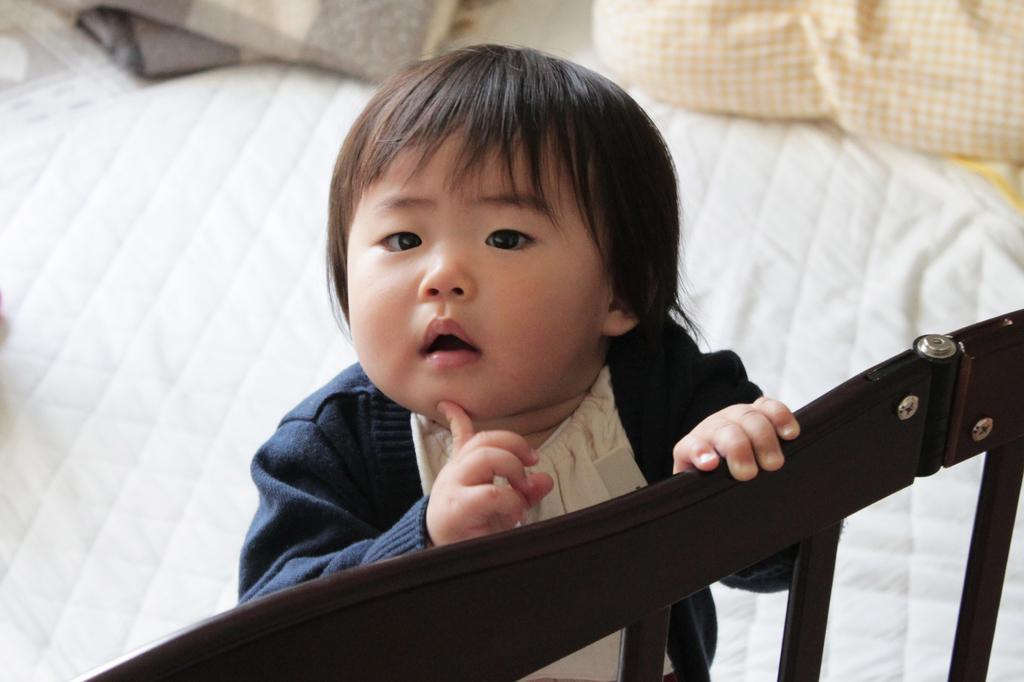In one or two sentences, can you explain what this image depicts? In the image we can see there is a little girl who is standing by taking support of a fencing which is in dark brown colour. The little girl is wearing navy blue colour jacket and she's on bed which is of white colour. 